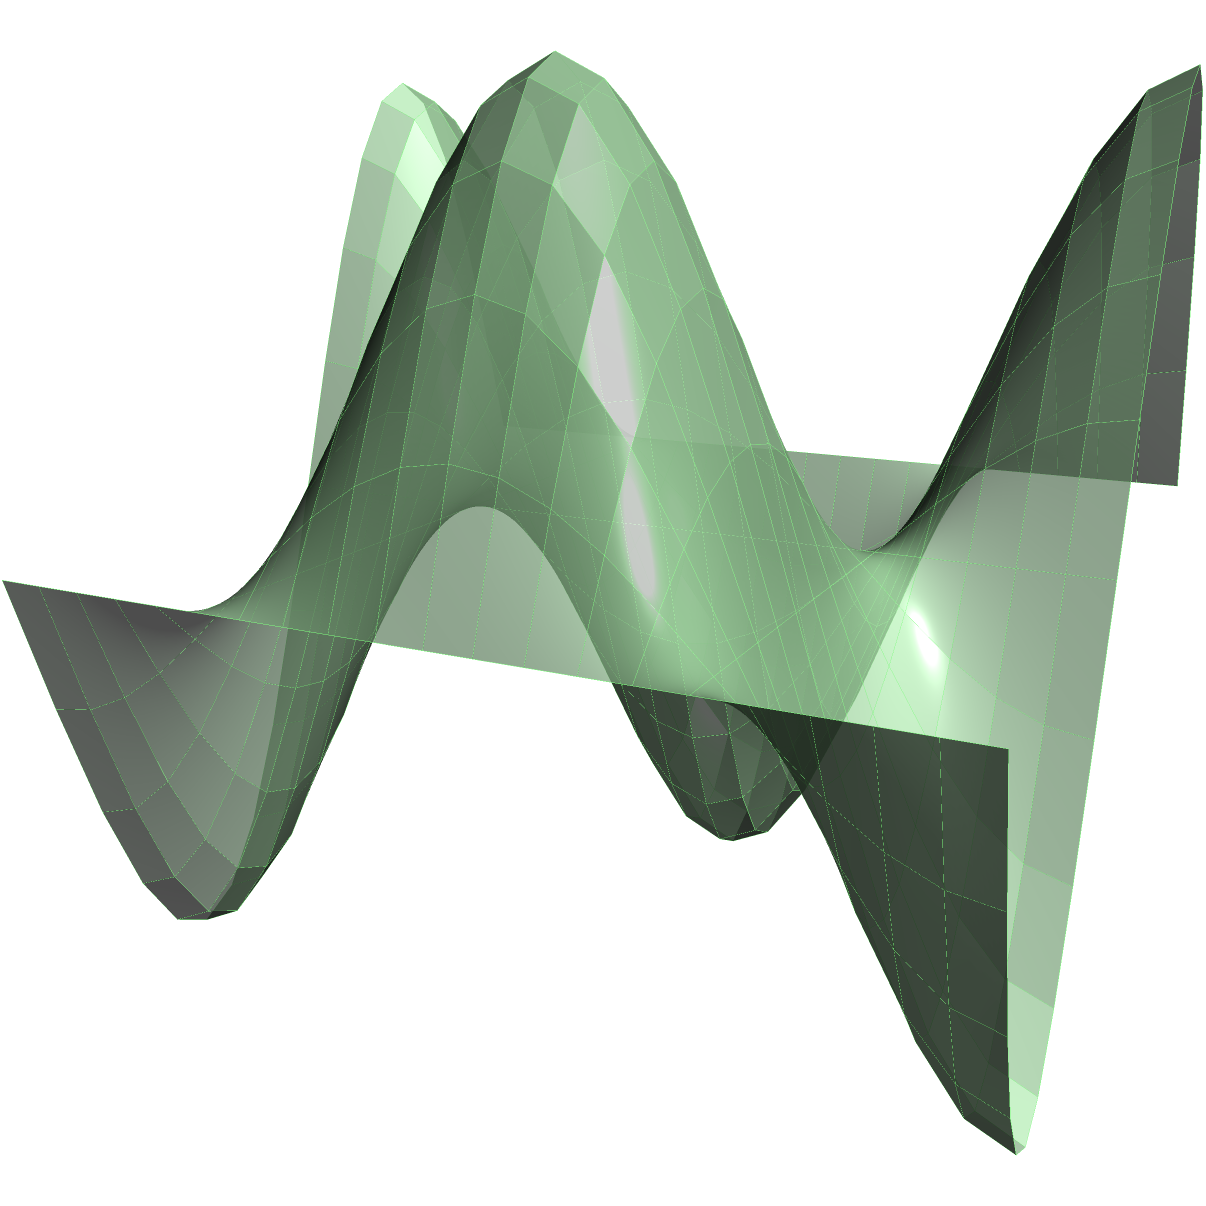A sedimentary basin is modeled by the surface $z = 2 + \sin(2\pi x)\cos(2\pi y)$ over the square region $0 \leq x \leq 1$, $0 \leq y \leq 1$. Calculate the volume of sediment in the basin using a triple integral. Round your answer to three decimal places. To calculate the volume of the sedimentary basin, we need to set up and evaluate a triple integral. Here's the step-by-step process:

1) The volume is given by the triple integral:
   $$V = \iiint_V dV = \int_0^1 \int_0^1 \int_0^{2 + \sin(2\pi x)\cos(2\pi y)} dz \, dy \, dx$$

2) Evaluate the innermost integral with respect to z:
   $$V = \int_0^1 \int_0^1 [z]_0^{2 + \sin(2\pi x)\cos(2\pi y)} dy \, dx$$
   $$V = \int_0^1 \int_0^1 [2 + \sin(2\pi x)\cos(2\pi y)] dy \, dx$$

3) Now we have a double integral:
   $$V = \int_0^1 \int_0^1 2 \, dy \, dx + \int_0^1 \int_0^1 \sin(2\pi x)\cos(2\pi y) \, dy \, dx$$

4) The first part is straightforward:
   $$\int_0^1 \int_0^1 2 \, dy \, dx = 2$$

5) For the second part, we can use the identity $\int_0^1 \cos(2\pi y) \, dy = 0$:
   $$\int_0^1 \int_0^1 \sin(2\pi x)\cos(2\pi y) \, dy \, dx = \int_0^1 \sin(2\pi x) \left[\int_0^1 \cos(2\pi y) \, dy\right] dx = 0$$

6) Therefore, the final result is:
   $$V = 2 + 0 = 2$$

7) Rounding to three decimal places: 2.000
Answer: 2.000 cubic units 